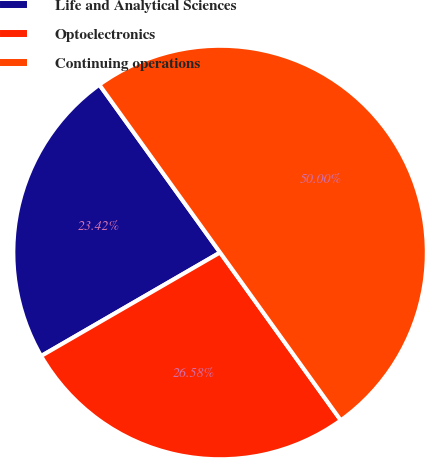Convert chart to OTSL. <chart><loc_0><loc_0><loc_500><loc_500><pie_chart><fcel>Life and Analytical Sciences<fcel>Optoelectronics<fcel>Continuing operations<nl><fcel>23.42%<fcel>26.58%<fcel>50.0%<nl></chart> 